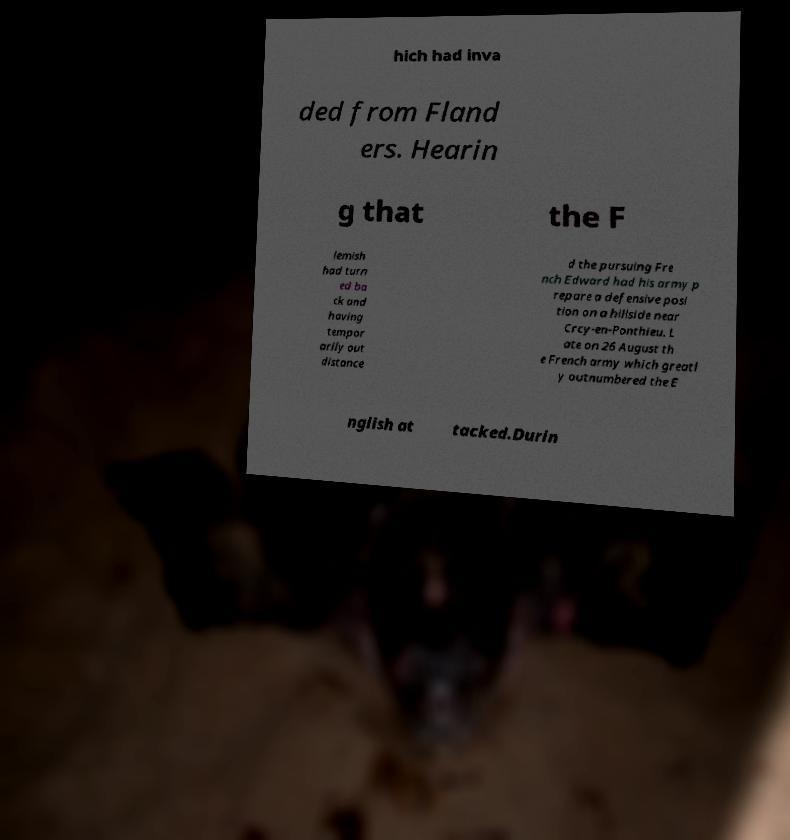Could you assist in decoding the text presented in this image and type it out clearly? hich had inva ded from Fland ers. Hearin g that the F lemish had turn ed ba ck and having tempor arily out distance d the pursuing Fre nch Edward had his army p repare a defensive posi tion on a hillside near Crcy-en-Ponthieu. L ate on 26 August th e French army which greatl y outnumbered the E nglish at tacked.Durin 